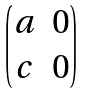<formula> <loc_0><loc_0><loc_500><loc_500>\begin{pmatrix} a & 0 \\ c & 0 \end{pmatrix}</formula> 